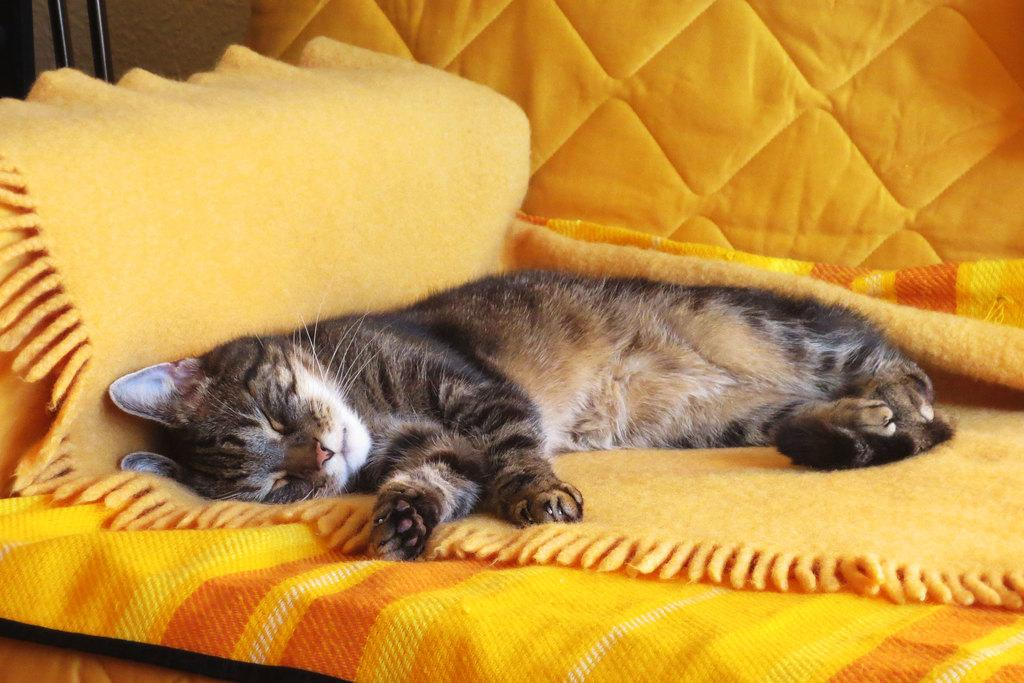What type of animal is in the image? There is a cat in the image. What is the cat doing in the image? The cat is sleeping. On what surface is the cat resting? The cat is on a yellow surface. What color is the background of the image? The background of the image is yellow. How many pigs are visible in the image? There are no pigs present in the image; it features a cat. What is the chance of the cat waking up in the next hour? It is impossible to determine the cat's chance of waking up in the next hour based on the image alone. 